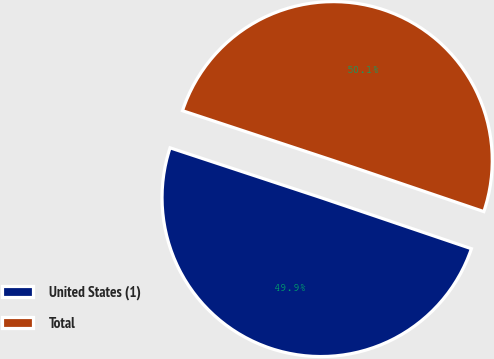Convert chart to OTSL. <chart><loc_0><loc_0><loc_500><loc_500><pie_chart><fcel>United States (1)<fcel>Total<nl><fcel>49.87%<fcel>50.13%<nl></chart> 